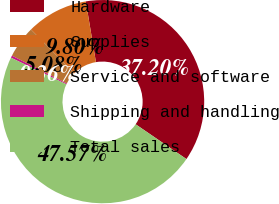<chart> <loc_0><loc_0><loc_500><loc_500><pie_chart><fcel>Hardware<fcel>Supplies<fcel>Service and software<fcel>Shipping and handling<fcel>Total sales<nl><fcel>37.2%<fcel>9.8%<fcel>5.08%<fcel>0.36%<fcel>47.57%<nl></chart> 